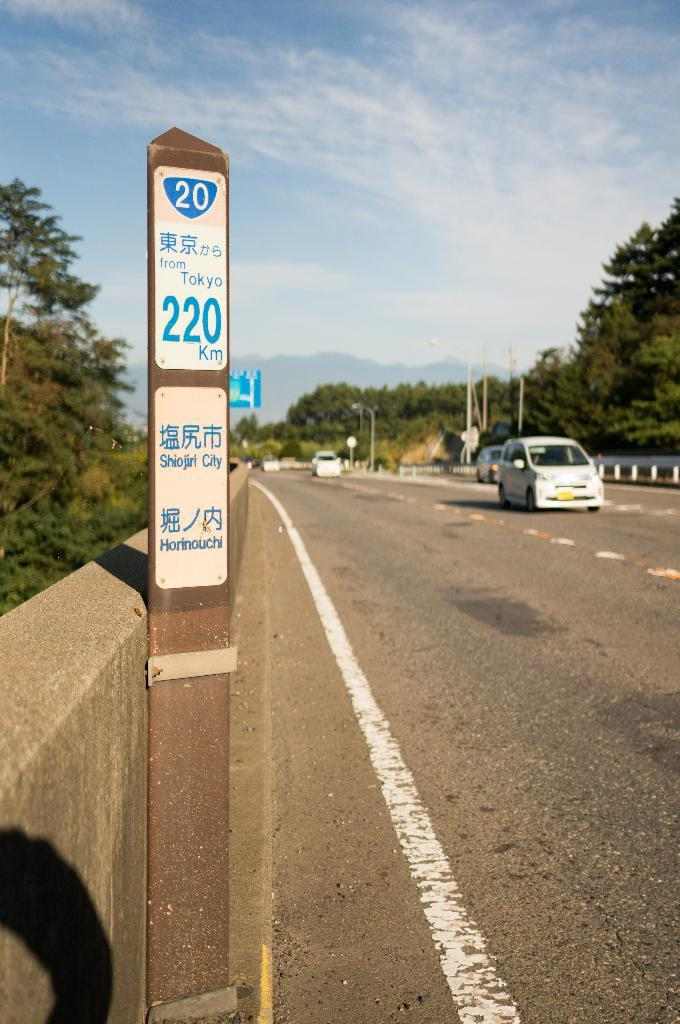<image>
Share a concise interpretation of the image provided. A 220km mileage marker with vehicles coming towards it. 